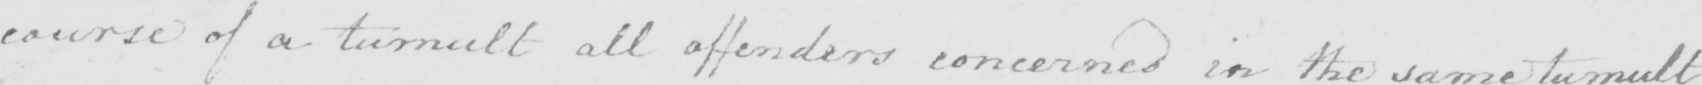Can you tell me what this handwritten text says? course of a tumult all offenders concerned in the same tumult 